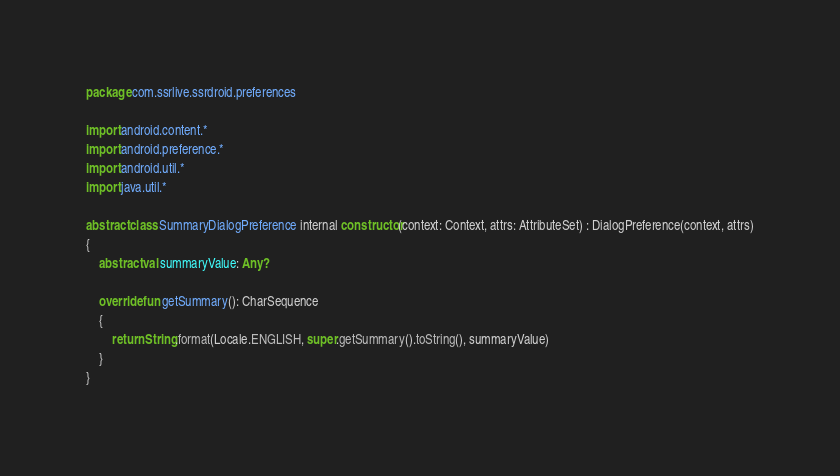<code> <loc_0><loc_0><loc_500><loc_500><_Kotlin_>package com.ssrlive.ssrdroid.preferences

import android.content.*
import android.preference.*
import android.util.*
import java.util.*

abstract class SummaryDialogPreference internal constructor(context: Context, attrs: AttributeSet) : DialogPreference(context, attrs)
{
	abstract val summaryValue: Any?

	override fun getSummary(): CharSequence
	{
		return String.format(Locale.ENGLISH, super.getSummary().toString(), summaryValue)
	}
}
</code> 